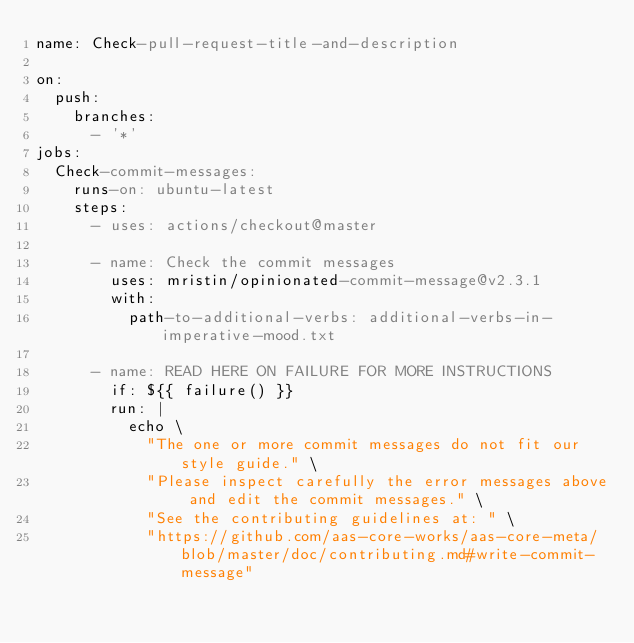Convert code to text. <code><loc_0><loc_0><loc_500><loc_500><_YAML_>name: Check-pull-request-title-and-description

on:
  push:
    branches:
      - '*'
jobs:
  Check-commit-messages:
    runs-on: ubuntu-latest
    steps:
      - uses: actions/checkout@master

      - name: Check the commit messages
        uses: mristin/opinionated-commit-message@v2.3.1
        with:
          path-to-additional-verbs: additional-verbs-in-imperative-mood.txt

      - name: READ HERE ON FAILURE FOR MORE INSTRUCTIONS
        if: ${{ failure() }}
        run: |
          echo \
            "The one or more commit messages do not fit our style guide." \
            "Please inspect carefully the error messages above and edit the commit messages." \
            "See the contributing guidelines at: " \
            "https://github.com/aas-core-works/aas-core-meta/blob/master/doc/contributing.md#write-commit-message"
</code> 